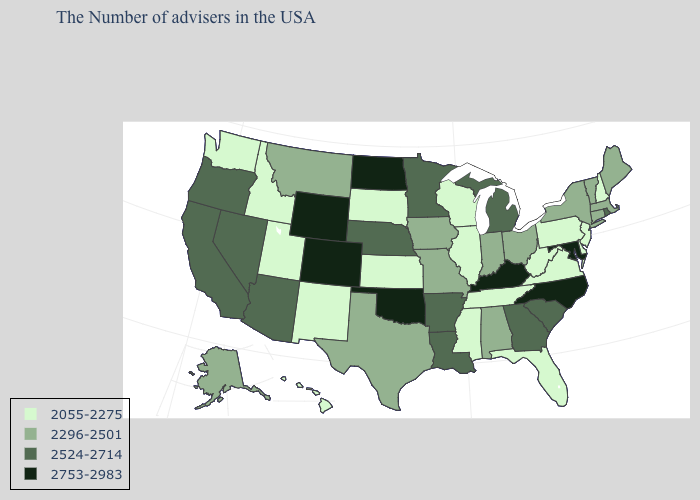What is the value of Alaska?
Give a very brief answer. 2296-2501. Which states have the highest value in the USA?
Answer briefly. Maryland, North Carolina, Kentucky, Oklahoma, North Dakota, Wyoming, Colorado. Name the states that have a value in the range 2055-2275?
Write a very short answer. New Hampshire, New Jersey, Delaware, Pennsylvania, Virginia, West Virginia, Florida, Tennessee, Wisconsin, Illinois, Mississippi, Kansas, South Dakota, New Mexico, Utah, Idaho, Washington, Hawaii. Among the states that border West Virginia , does Ohio have the highest value?
Write a very short answer. No. What is the lowest value in states that border Indiana?
Be succinct. 2055-2275. What is the value of Missouri?
Be succinct. 2296-2501. Name the states that have a value in the range 2055-2275?
Be succinct. New Hampshire, New Jersey, Delaware, Pennsylvania, Virginia, West Virginia, Florida, Tennessee, Wisconsin, Illinois, Mississippi, Kansas, South Dakota, New Mexico, Utah, Idaho, Washington, Hawaii. Name the states that have a value in the range 2753-2983?
Be succinct. Maryland, North Carolina, Kentucky, Oklahoma, North Dakota, Wyoming, Colorado. What is the value of California?
Answer briefly. 2524-2714. Among the states that border Tennessee , which have the lowest value?
Write a very short answer. Virginia, Mississippi. Does Pennsylvania have the highest value in the USA?
Short answer required. No. Does Maryland have the highest value in the USA?
Give a very brief answer. Yes. What is the lowest value in states that border Rhode Island?
Write a very short answer. 2296-2501. What is the value of South Carolina?
Be succinct. 2524-2714. Does the map have missing data?
Short answer required. No. 